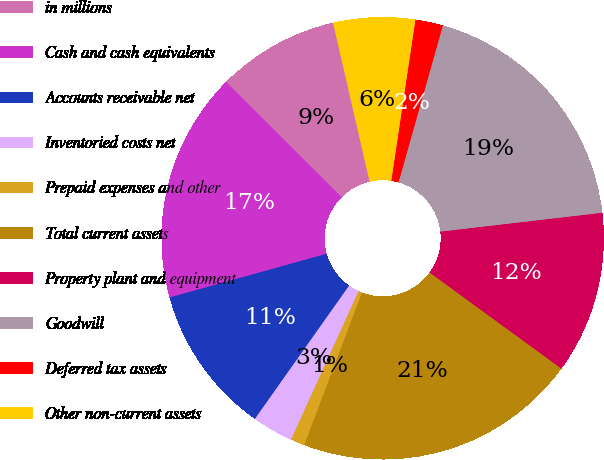Convert chart. <chart><loc_0><loc_0><loc_500><loc_500><pie_chart><fcel>in millions<fcel>Cash and cash equivalents<fcel>Accounts receivable net<fcel>Inventoried costs net<fcel>Prepaid expenses and other<fcel>Total current assets<fcel>Property plant and equipment<fcel>Goodwill<fcel>Deferred tax assets<fcel>Other non-current assets<nl><fcel>8.92%<fcel>16.8%<fcel>10.89%<fcel>3.0%<fcel>1.03%<fcel>20.74%<fcel>11.87%<fcel>18.77%<fcel>2.02%<fcel>5.96%<nl></chart> 